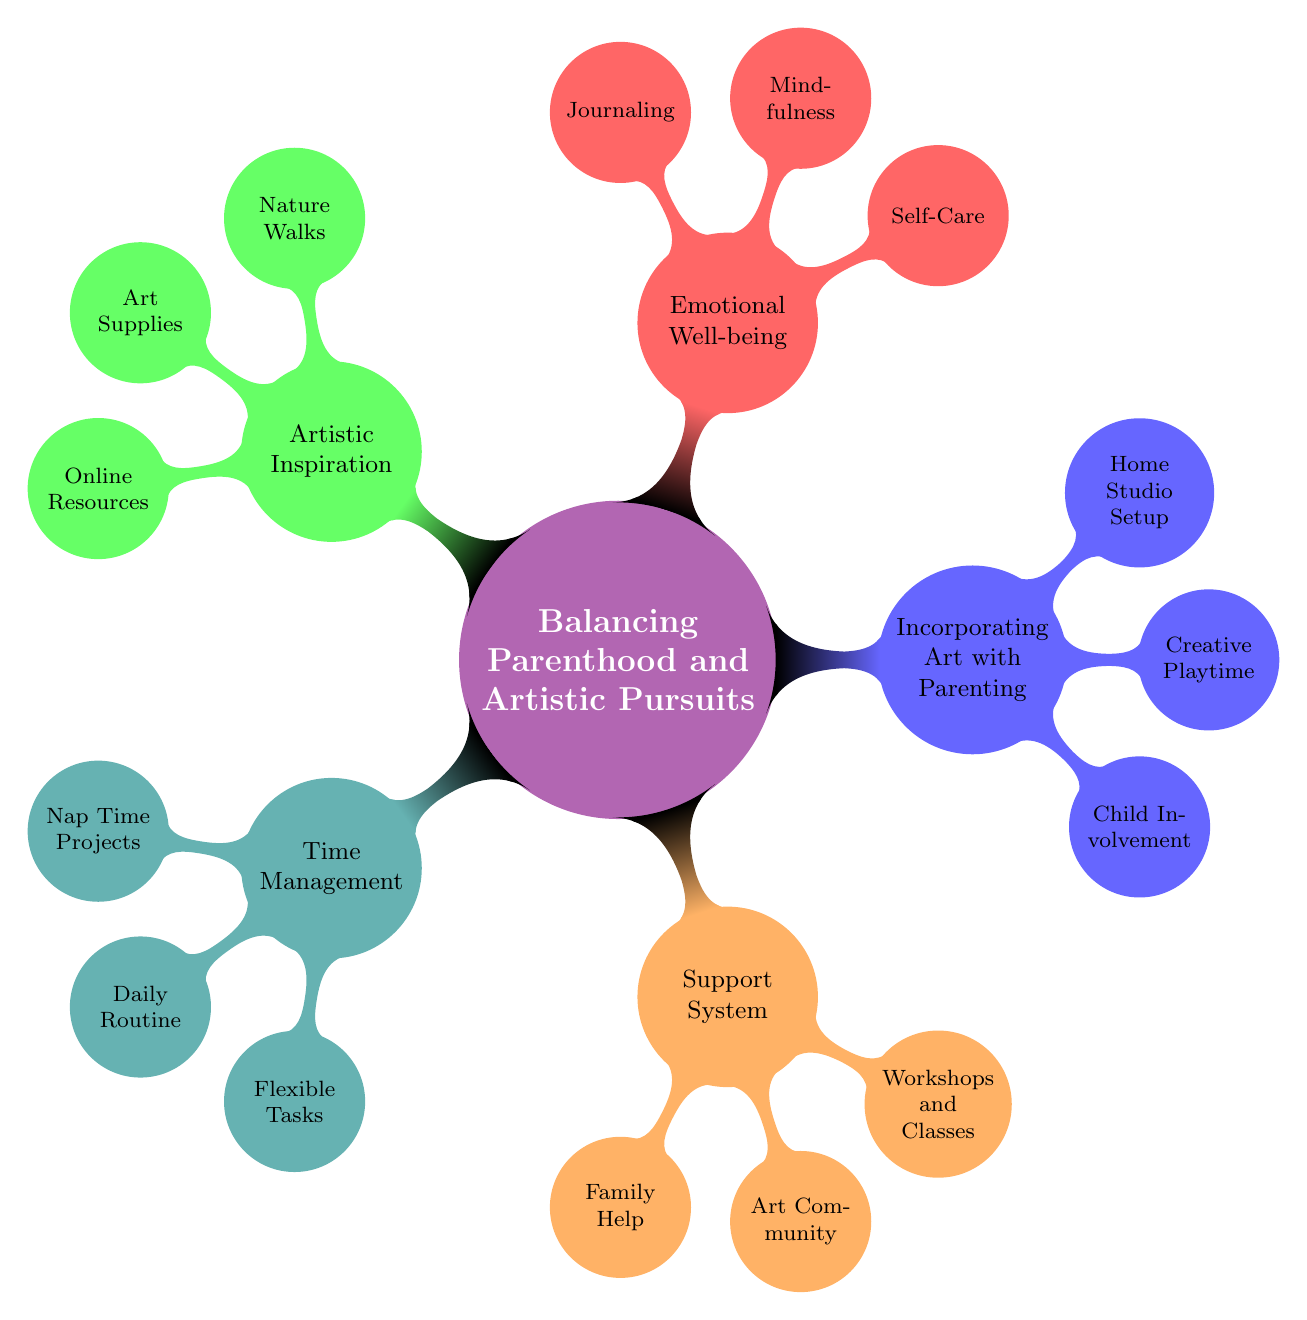What is the central theme of the mind map? The central theme is located at the top of the diagram, which is "Balancing Parenthood and Artistic Pursuits."
Answer: Balancing Parenthood and Artistic Pursuits How many main branches are in the mind map? The diagram has five main branches extending from the central theme, representing major categories.
Answer: 5 What is one example of incorporating art with parenting? Looking at the "Incorporating Art with Parenting" branch, "Child Involvement" is one example mentioned there.
Answer: Child Involvement Which branch discusses emotional well-being? In the diagram, the branch labeled "Emotional Well-being" directly addresses this topic.
Answer: Emotional Well-being What is one method for time management in the mind map? The "Time Management" branch has "Nap Time Projects" listed as a method for managing time effectively.
Answer: Nap Time Projects How does the support system relate to artistic pursuits? The "Support System" branch contains elements that collaboratively assist in balancing parenting and art, such as engaging with the "Art Community."
Answer: Art Community What are two activities listed under artistic inspiration? Under the "Artistic Inspiration" branch, both "Nature Walks" and "Online Resources" are mentioned as activities.
Answer: Nature Walks, Online Resources How is self-care categorized in the mind map? The mind map mentions "Self-Care" under the "Emotional Well-being" branch, indicating its importance in the overall balance sought.
Answer: Self-Care What do "Workshops and Classes" provide according to the support system? They are included in the "Support System" branch and suggest options that include childcare, aiding parents who want to pursue art.
Answer: Workshops and Classes 